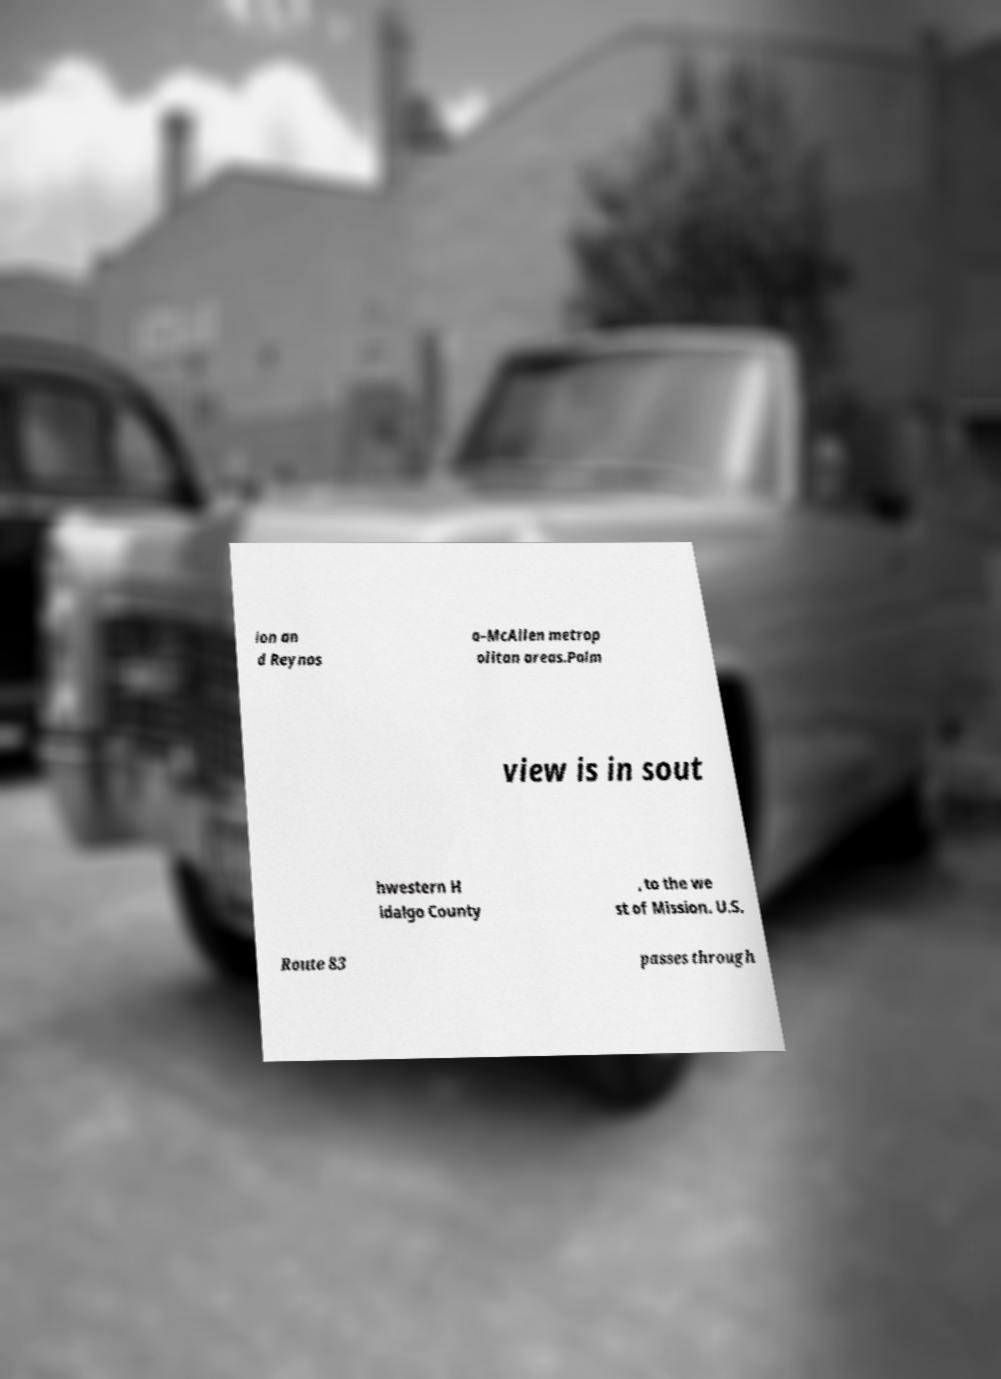I need the written content from this picture converted into text. Can you do that? ion an d Reynos a–McAllen metrop olitan areas.Palm view is in sout hwestern H idalgo County , to the we st of Mission. U.S. Route 83 passes through 